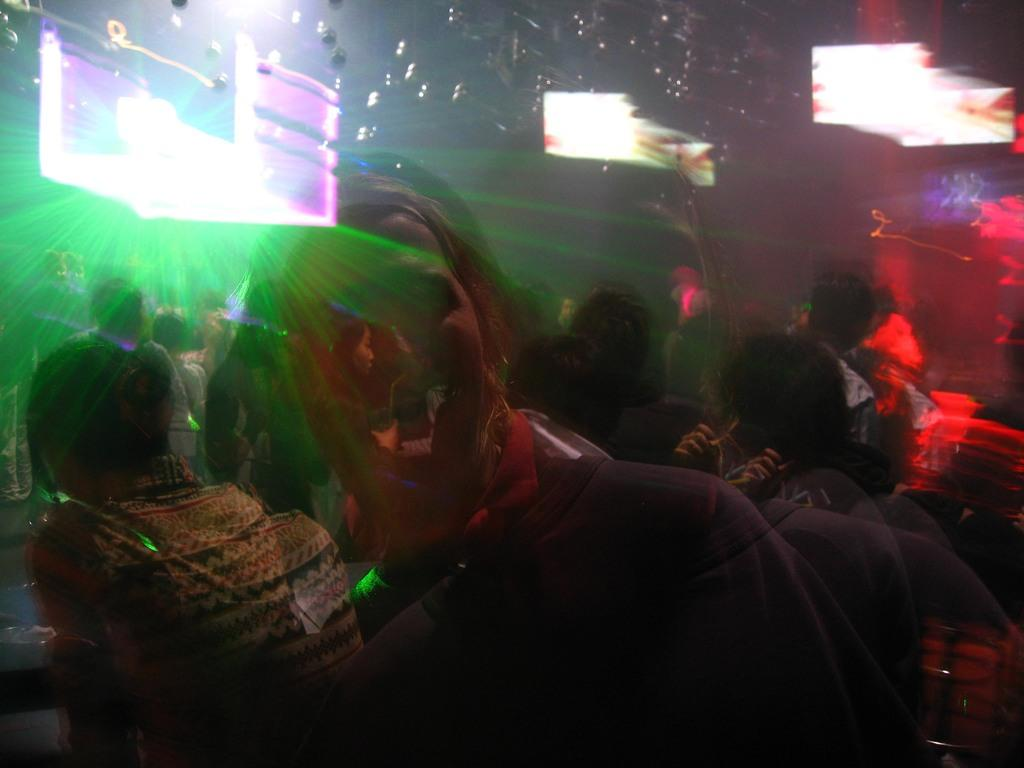What is the main subject in the center of the image? There is a crowd in the center of the image. What can be seen in the background of the image? There are screens and lights in the background of the image. What type of rake is being used by the crowd in the image? There is no rake present in the image; the main subject is a crowd. 